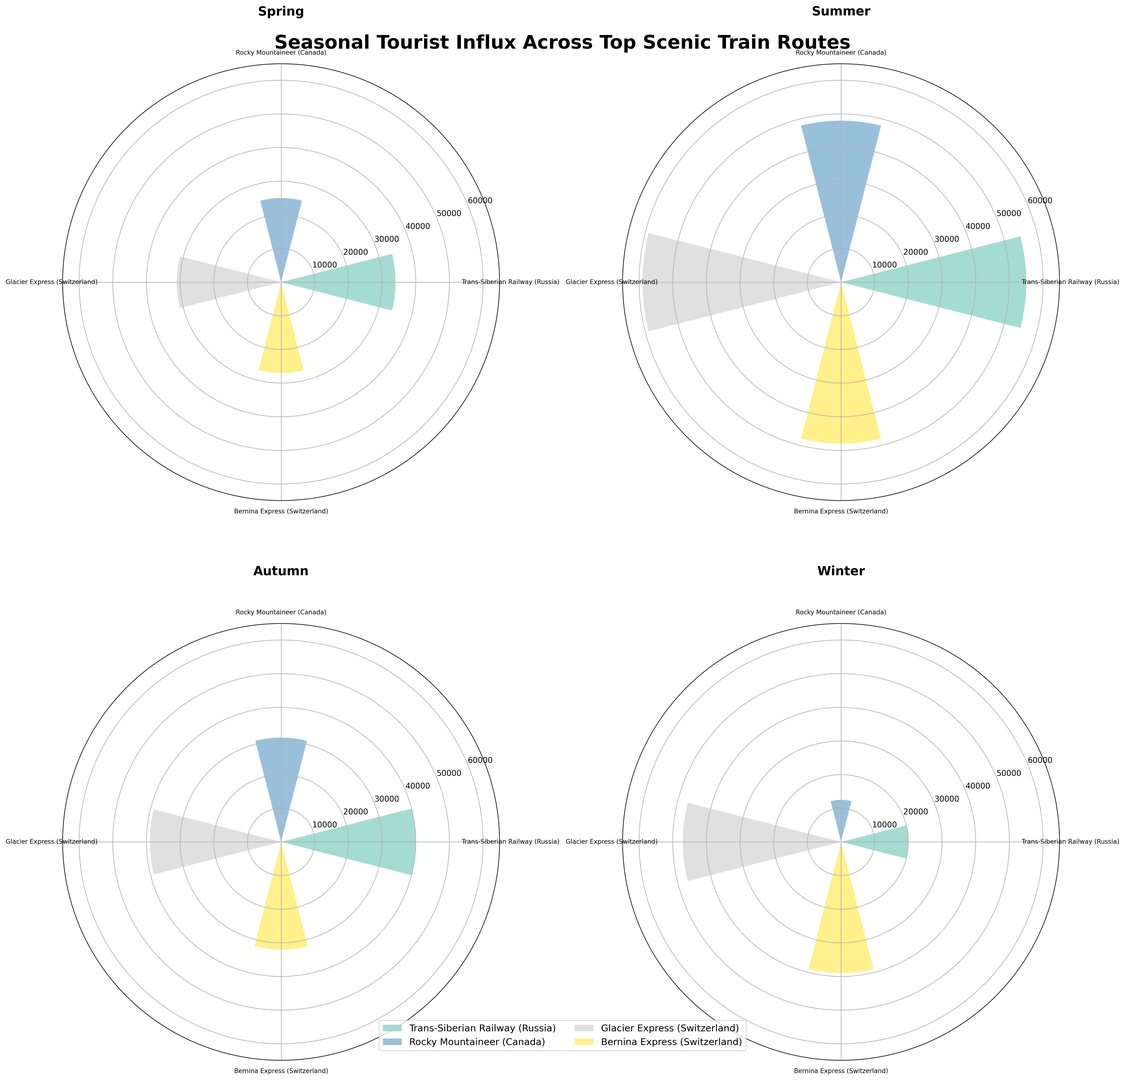What's the total number of tourists for the Trans-Siberian Railway in Summer? To find the total number of tourists for the Trans-Siberian Railway in Summer, look at the individual tourist numbers for each country: Russia (25000), China (12000), Germany (10000), and UK (8000). Summing these values: 25000 + 12000 + 10000 + 8000 = 55000.
Answer: 55000 Which train route had the highest tourist influx in Winter? To determine the highest tourist influx in Winter, compare the total tourist numbers for all routes in Winter. The routes are: Trans-Siberian Railway (10000 + 5000 + 3000 + 2000 = 20000), Rocky Mountaineer (5000 + 4000 + 2000 + 1500 = 12500), Glacier Express (18000 + 12000 + 9000 + 8000 = 47000), Bernina Express (15000 + 10000 + 8000 + 6000 = 39000). Glacier Express has the highest influx.
Answer: Glacier Express For the Rocky Mountaineer, how does the tourist influx in Spring compare to Autumn? Look at the Rocky Mountaineer's tourist numbers for Spring and Autumn. Spring: Canada (10000), USA (8000), UK (4000), Australia (3000), total = 25000. Autumn: Canada (12000), USA (10000), UK (5000), Australia (4000), total = 31000. Compare the totals: 31000 - 25000 = 6000. Autumn has 6000 more tourists than Spring.
Answer: 6000 more in Autumn Which season has the lowest tourist influx for the Bernina Express? To find the lowest tourist influx season for the Bernina Express, compare the totals for each season. Spring: 10000 + 7000 + 6000 + 4000 = 27000; Summer: 18000 + 12000 + 10000 + 8000 = 48000; Autumn: 12000 + 8000 + 7000 + 5000 = 32000; Winter: 15000 + 10000 + 8000 + 6000 = 39000. Spring has the lowest influx.
Answer: Spring How does the tourist influx for the Glacier Express in Summer compare to the Trans-Siberian Railway in the same season? Compare the total tourists for both routes in Summer. Glacier Express: Switzerland (22000), Germany (15000), UK (12000), USA (10000) = 59000. Trans-Siberian Railway: Russia (25000), China (12000), Germany (10000), UK (8000) = 55000. Subtract Trans-Siberian Railway total from Glacier Express total: 59000 - 55000 = 4000. Glacier Express has 4000 more tourists.
Answer: Glacier Express has 4000 more tourists What is the average number of tourists per country for the Bernina Express in Winter? For Bernina Express in Winter, sum the tourist numbers and divide by the number of countries. Numbers: Switzerland (15000), Italy (10000), Germany (8000), UK (6000). Total = 15000 + 10000 + 8000 + 6000 = 39000. There are 4 countries. Average = 39000 / 4 = 9750.
Answer: 9750 Which country contributes the most tourists to the Glacier Express in Spring? Look at the number of tourists by each country for the Glacier Express in Spring. Switzerland (12000), Germany (8000), UK (6000), USA (5000). Switzerland has the highest number.
Answer: Switzerland How does the tourist trend for UK differ between Rocky Mountaineer and Glacier Express across the seasons? For Rocky Mountaineer, UK tourists: Spring (4000), Summer (7000), Autumn (5000), Winter (2000). Total = 18000. For Glacier Express, UK tourists: Spring (6000), Summer (12000), Autumn (8000), Winter (9000). Total = 35000. The Glacier Express has a higher and more consistent UK tourist trend across seasons compared to Rocky Mountaineer.
Answer: Glacier Express has a higher and more consistent UK tourist trend 